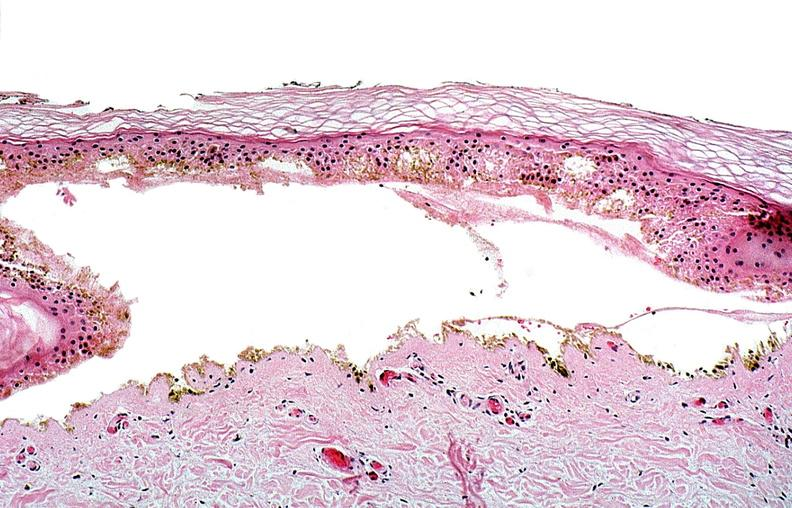what does this image show?
Answer the question using a single word or phrase. Thermal burned skin 